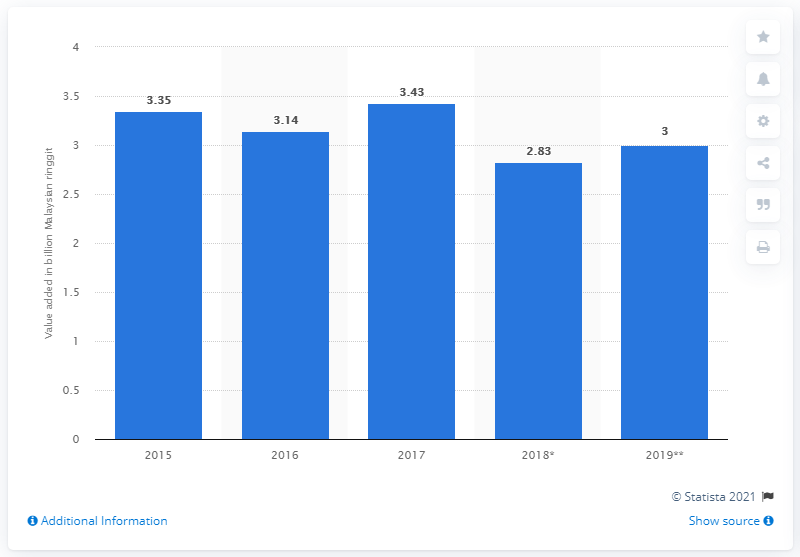Identify some key points in this picture. Based on forecasts, the expected gross domestic product from the rubber industry in 2019 was approximately 3... 